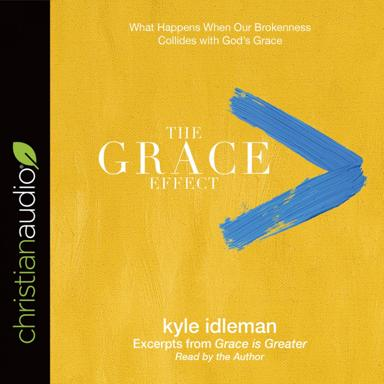How is the work presented according to the image? As shown in the bright yellow and blue cover art of the image, "The Grace Effect" is an audiobook offered by Christian Audio. It provides a dynamic listening experience, narrated by the original author, Kyle Idleman, which allows the audience to engage with the transformative messages from "Grace is Greater" through the intimate context of the spoken word. 